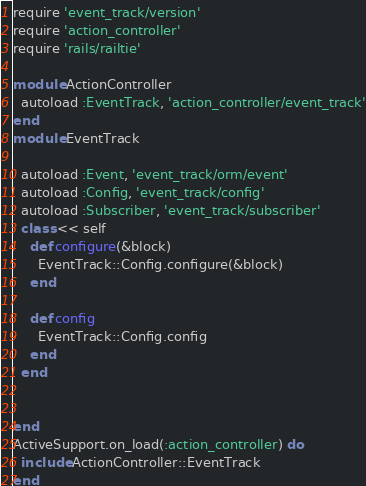Convert code to text. <code><loc_0><loc_0><loc_500><loc_500><_Ruby_>require 'event_track/version'
require 'action_controller'
require 'rails/railtie'

module ActionController
  autoload :EventTrack, 'action_controller/event_track'
end
module EventTrack

  autoload :Event, 'event_track/orm/event'
  autoload :Config, 'event_track/config'
  autoload :Subscriber, 'event_track/subscriber'
  class << self
    def configure(&block)
      EventTrack::Config.configure(&block)
    end

    def config
      EventTrack::Config.config
    end
  end


end
ActiveSupport.on_load(:action_controller) do
  include ActionController::EventTrack
end
</code> 